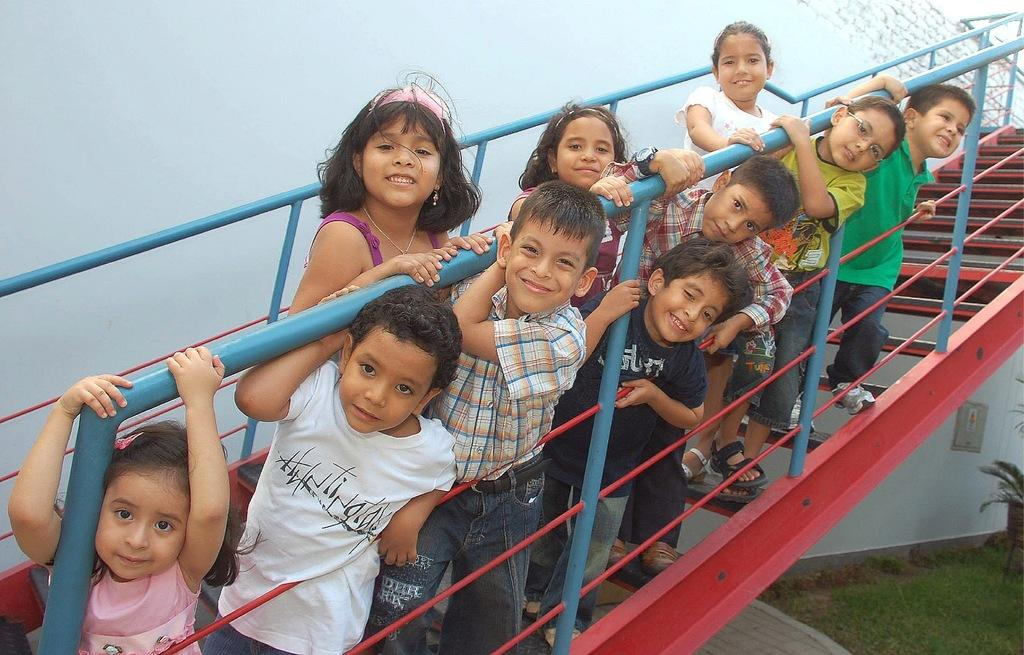Who is present in the image? There are children in the image. Where are the children located? The children are on a staircase. What is the staircase attached to? The staircase is attached to a building. What type of surface is visible on the ground in the image? There is grass on the ground in the image. What type of vegetation can be seen in the image? There is a plant in the image. What type of dolls are being used to build the brick wall in the image? There are no dolls or brick walls present in the image; it features children on a staircase attached to a building, with grass and a plant visible. 